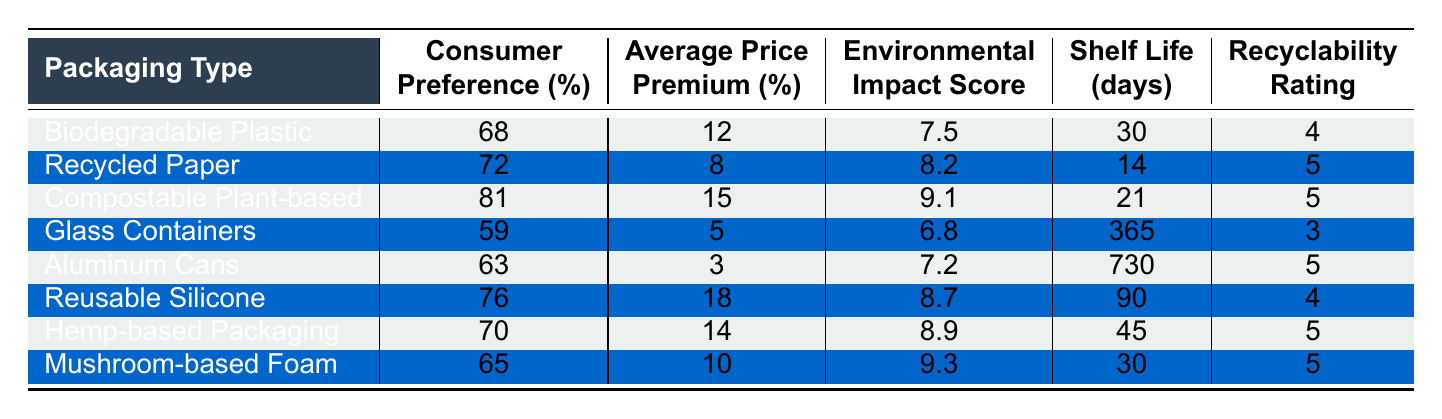What is the environmental impact score of compostable plant-based packaging? The environmental impact score for compostable plant-based packaging is listed directly in the table, where it shows a score of 9.1.
Answer: 9.1 Which packaging type has the highest consumer preference percentage? By examining the 'Consumer Preference (%)' column, compostable plant-based packaging has the highest percentage at 81%.
Answer: 81% What is the average price premium for biodegradable plastic packaging? The table indicates that the average price premium for biodegradable plastic packaging is 12%.
Answer: 12% Is the recyclability rating for glass containers higher than for biodegradable plastic? The recyclability rating for glass containers is 3, while for biodegradable plastic, it is 4. Therefore, the rating for glass containers is not higher.
Answer: No Calculate the average shelf life of all packaging types listed. First, add the shelf life values: 30 + 14 + 21 + 365 + 730 + 90 + 45 + 30 = 1325. Then divide by the number of types (8): 1325/8 = 165.625. The average shelf life is approximately 166 days.
Answer: 166 days How many packaging types have a consumer preference percentage above 70%? Reviewing the 'Consumer Preference (%)' column, the packaging types that exceed 70% are compostable plant-based (81%), recycled paper (72%), reusable silicone (76%), and hemp-based packaging (70%). This gives a total of 4 packaging types.
Answer: 4 What is the difference in average price premium between compostable plant-based and glass containers? The average price premium for compostable plant-based packaging is 15%, while for glass containers, it is 5%. The difference is 15 - 5 = 10%.
Answer: 10% Which packaging type has the longest shelf life and what is its value? The table shows that aluminum cans have the longest shelf life at 730 days.
Answer: 730 days Are there any packaging types with an environmental impact score of 9 or higher? Checking the 'Environmental Impact Score' column reveals that compostable plant-based packaging (9.1), mushroom-based foam (9.3), and hemp-based packaging (8.9) all meet this criterion.
Answer: Yes Identify the packaging type with the lowest average price premium and its corresponding value. The packaging type with the lowest average price premium is aluminum cans at 3%.
Answer: 3% 